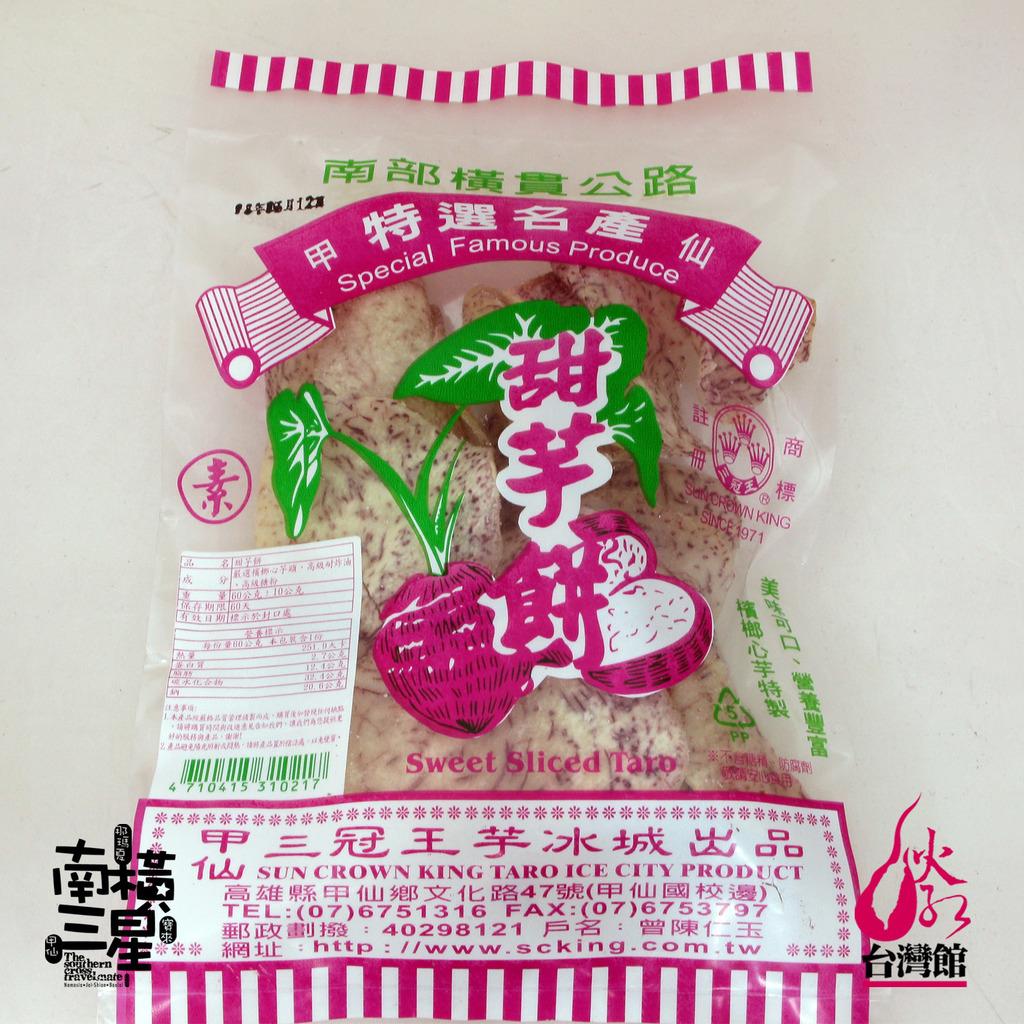What kind of tazo is this?
Your answer should be compact. Sweet sliced. 